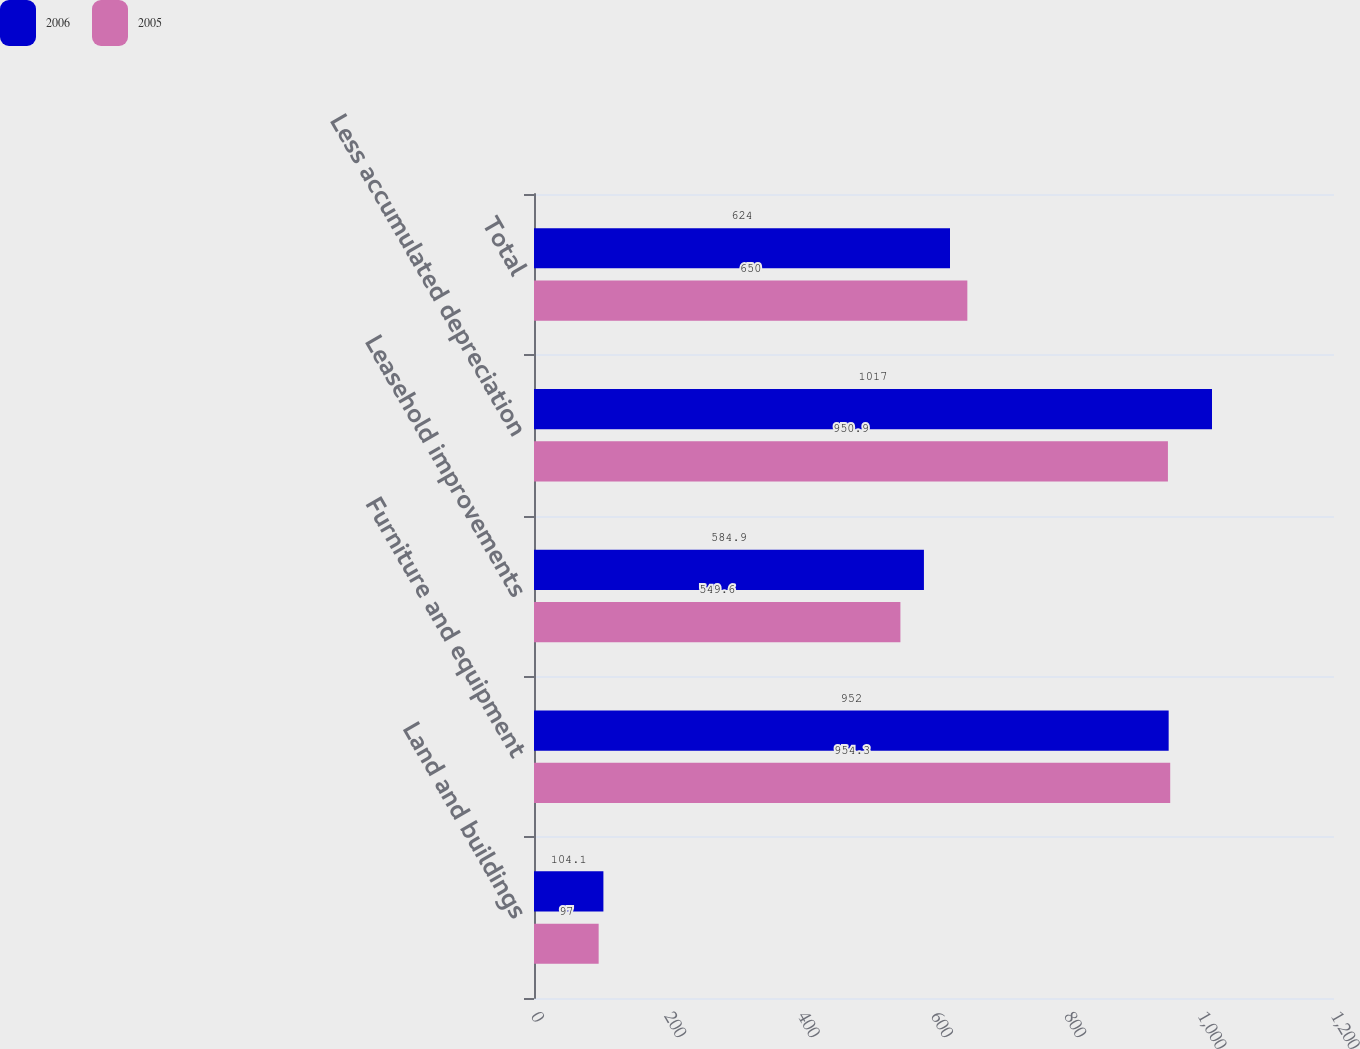Convert chart to OTSL. <chart><loc_0><loc_0><loc_500><loc_500><stacked_bar_chart><ecel><fcel>Land and buildings<fcel>Furniture and equipment<fcel>Leasehold improvements<fcel>Less accumulated depreciation<fcel>Total<nl><fcel>2006<fcel>104.1<fcel>952<fcel>584.9<fcel>1017<fcel>624<nl><fcel>2005<fcel>97<fcel>954.3<fcel>549.6<fcel>950.9<fcel>650<nl></chart> 